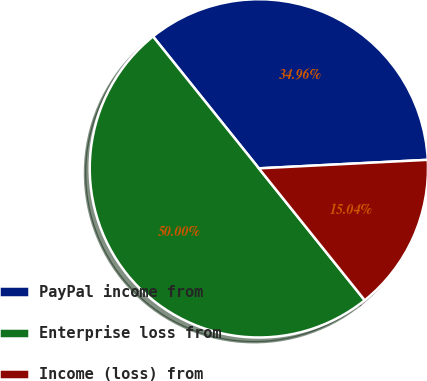Convert chart to OTSL. <chart><loc_0><loc_0><loc_500><loc_500><pie_chart><fcel>PayPal income from<fcel>Enterprise loss from<fcel>Income (loss) from<nl><fcel>34.96%<fcel>50.0%<fcel>15.04%<nl></chart> 